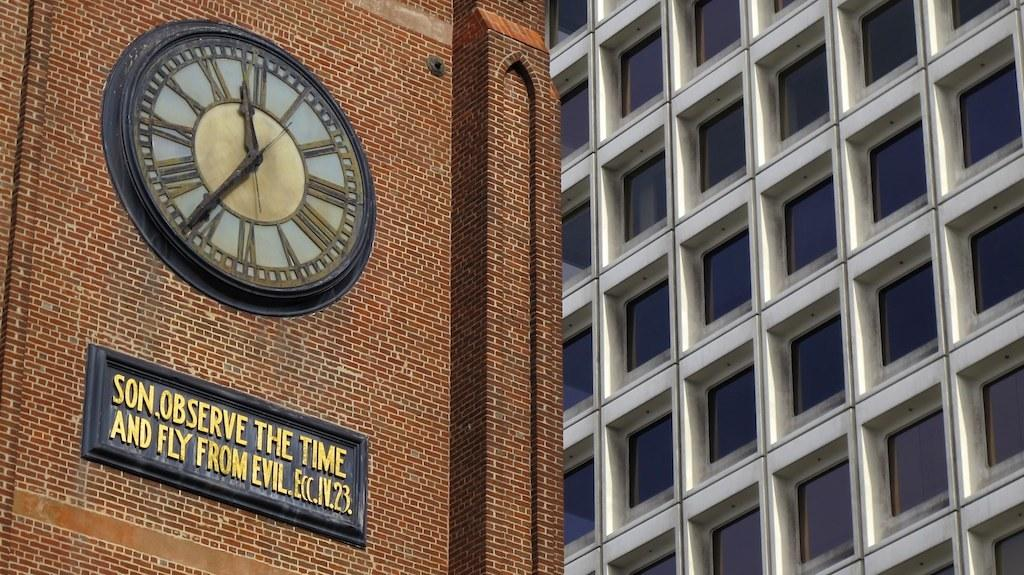<image>
Summarize the visual content of the image. A sign that says SON, OBSERVE THE TIME AND FLY FROM EVIL is on a brick wall below a clock. 